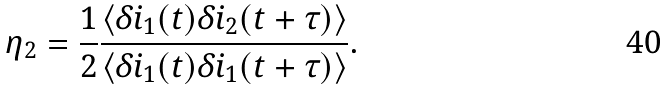<formula> <loc_0><loc_0><loc_500><loc_500>\eta _ { 2 } = \frac { 1 } { 2 } \frac { \langle \delta i _ { 1 } ( t ) \delta i _ { 2 } ( t + \tau ) \rangle } { \langle \delta i _ { 1 } ( t ) \delta i _ { 1 } ( t + \tau ) \rangle } .</formula> 